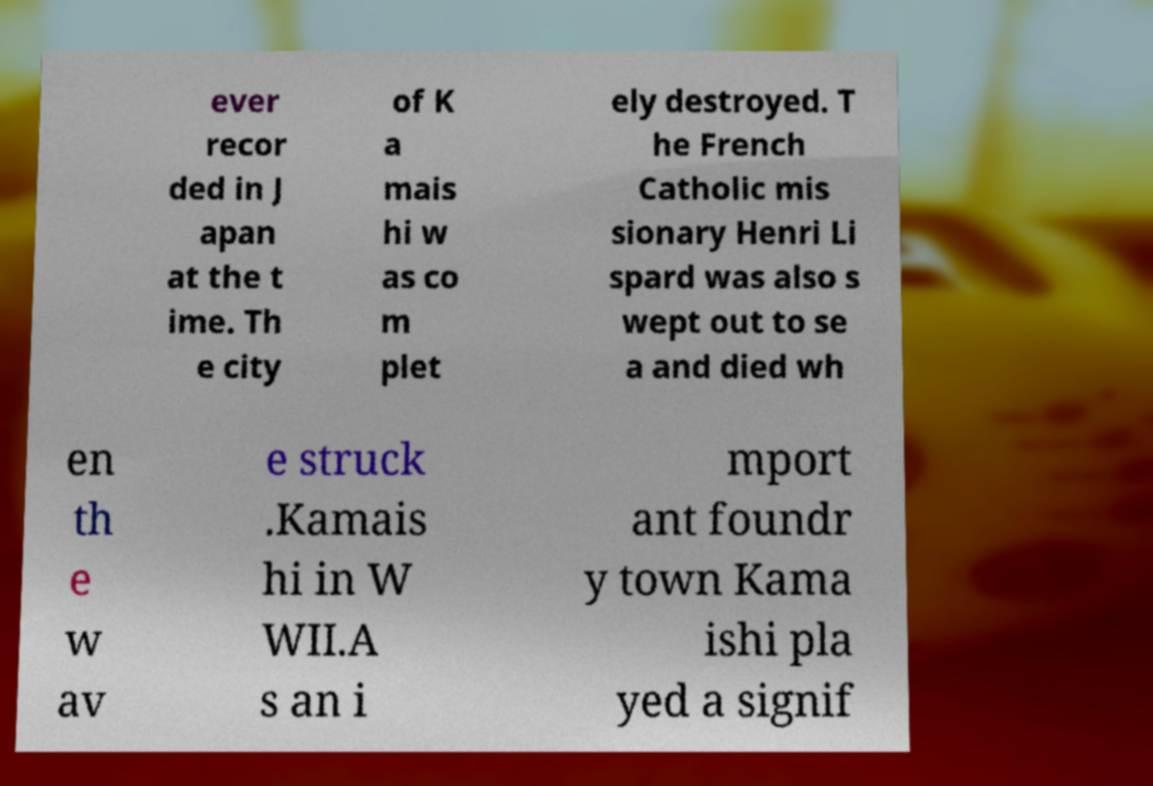What messages or text are displayed in this image? I need them in a readable, typed format. ever recor ded in J apan at the t ime. Th e city of K a mais hi w as co m plet ely destroyed. T he French Catholic mis sionary Henri Li spard was also s wept out to se a and died wh en th e w av e struck .Kamais hi in W WII.A s an i mport ant foundr y town Kama ishi pla yed a signif 